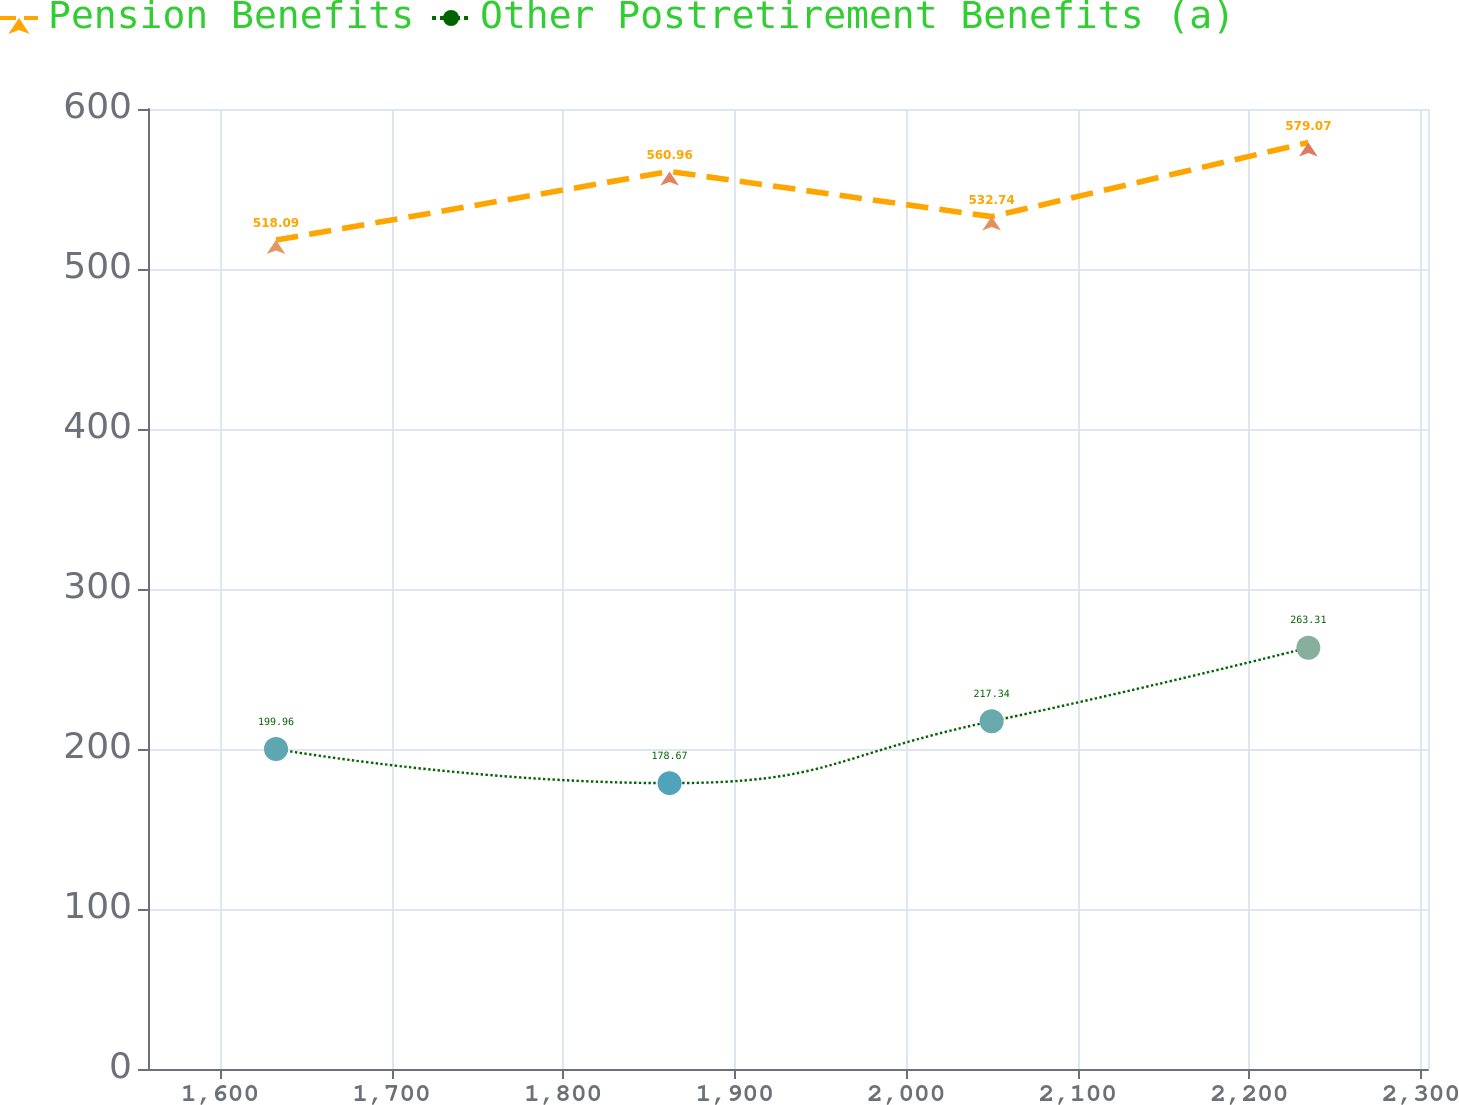Convert chart to OTSL. <chart><loc_0><loc_0><loc_500><loc_500><line_chart><ecel><fcel>Pension Benefits<fcel>Other Postretirement Benefits (a)<nl><fcel>1632.62<fcel>518.09<fcel>199.96<nl><fcel>1862.02<fcel>560.96<fcel>178.67<nl><fcel>2049.74<fcel>532.74<fcel>217.34<nl><fcel>2234.33<fcel>579.07<fcel>263.31<nl><fcel>2378.68<fcel>664.6<fcel>282.01<nl></chart> 